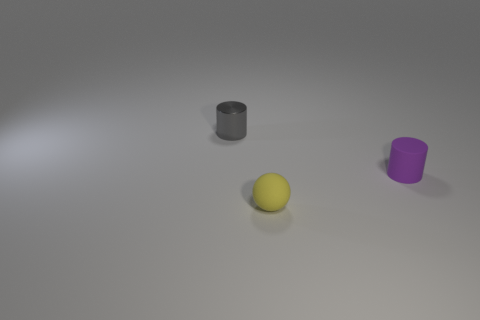What number of other tiny purple things have the same shape as the metal thing?
Your response must be concise. 1. What color is the matte cylinder that is the same size as the gray metal object?
Your answer should be very brief. Purple. What shape is the rubber thing that is on the right side of the tiny object in front of the tiny cylinder to the right of the gray cylinder?
Offer a very short reply. Cylinder. There is a tiny cylinder in front of the tiny gray metal cylinder; what number of things are left of it?
Ensure brevity in your answer.  2. Do the rubber object that is in front of the purple matte cylinder and the matte thing that is right of the yellow matte sphere have the same shape?
Provide a short and direct response. No. How many purple things are in front of the tiny matte ball?
Offer a terse response. 0. Are the tiny cylinder that is on the left side of the tiny purple object and the yellow object made of the same material?
Provide a short and direct response. No. What color is the other object that is the same shape as the tiny metallic object?
Your answer should be very brief. Purple. The gray thing is what shape?
Your answer should be very brief. Cylinder. What number of things are small gray objects or big matte spheres?
Your answer should be very brief. 1. 